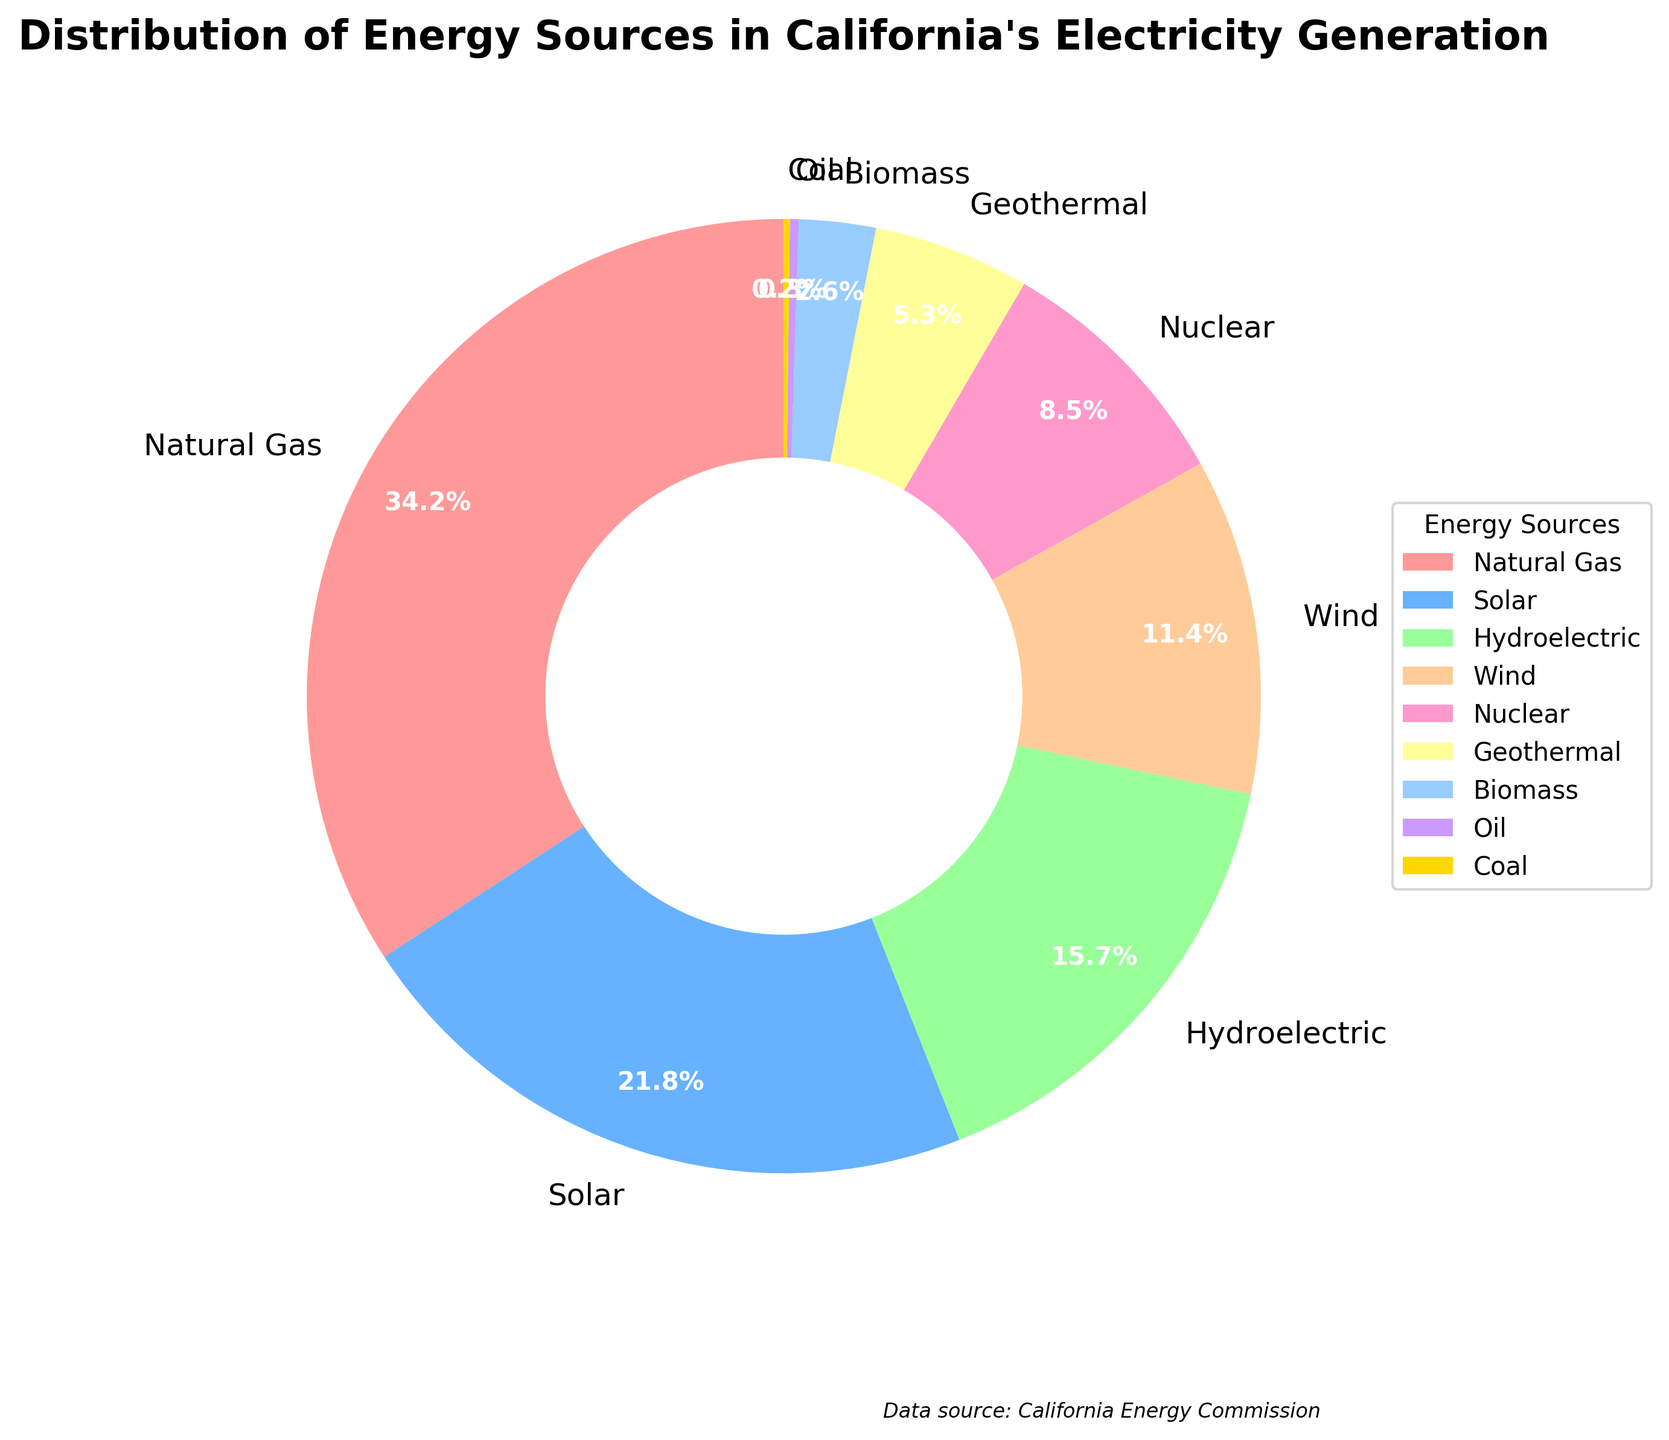What is the most common energy source for California's electricity generation? The biggest slice in the pie chart is labeled "Natural Gas" with 34.2%, making it the most common energy source.
Answer: Natural Gas Which two energy sources together constitute more than 50% of the electricity generation? Adding the percentage of Natural Gas (34.2%) and Solar (21.8%) gives a total of 34.2 + 21.8 = 56%, which is more than 50%.
Answer: Natural Gas and Solar How much more electricity generation is contributed by Solar compared to Wind? The percentage for Solar is 21.8% and for Wind is 11.4%. Subtract 11.4 from 21.8 to get the difference: 21.8 - 11.4 = 10.4%.
Answer: 10.4% What percentage of electricity generation comes from both Geothermal and Biomass combined? Geothermal contributes 5.3% and Biomass contributes 2.6%. Adding them together gives: 5.3 + 2.6 = 7.9%.
Answer: 7.9% Which energy source contributes the least to California's electricity generation? The smallest slice in the pie chart is labeled "Coal" with 0.2%, making it the least contributing source.
Answer: Coal How do the contributions of Hydroelectric and Nuclear compare? Hydroelectric contributes 15.7% while Nuclear contributes 8.5%. Hydroelectric contributes more as 15.7 is greater than 8.5.
Answer: Hydroelectric contributes more Which sources contribute less than 5% each to electricity generation? The slices labeled Geothermal (5.3%), Biomass (2.6%), Oil (0.3%), and Coal (0.2%) each contribute less than 5%. Geothermal is slightly above the threshold so exclude it.
Answer: Biomass, Oil, and Coal What is the total contribution of renewable energy sources (Solar, Wind, Hydroelectric, Geothermal, Biomass)? Sum of Solar (21.8%), Wind (11.4%), Hydroelectric (15.7%), Geothermal (5.3%), and Biomass (2.6%) is 21.8 + 11.4 + 15.7 + 5.3 + 2.6 = 56.8%.
Answer: 56.8% How does the contribution of Oil compare to that of Natural Gas? Oil contributes 0.3% while Natural Gas contributes 34.2%. Oil's contribution is significantly smaller as 0.3 is much less than 34.2.
Answer: Oil contributes much less Which energy source's contribution is closest to Nuclear's contribution? Nuclear contributes 8.5%. The closest contribution to this is Geothermal, contributing 5.3%, as it is the closest in percentage value.
Answer: Geothermal 